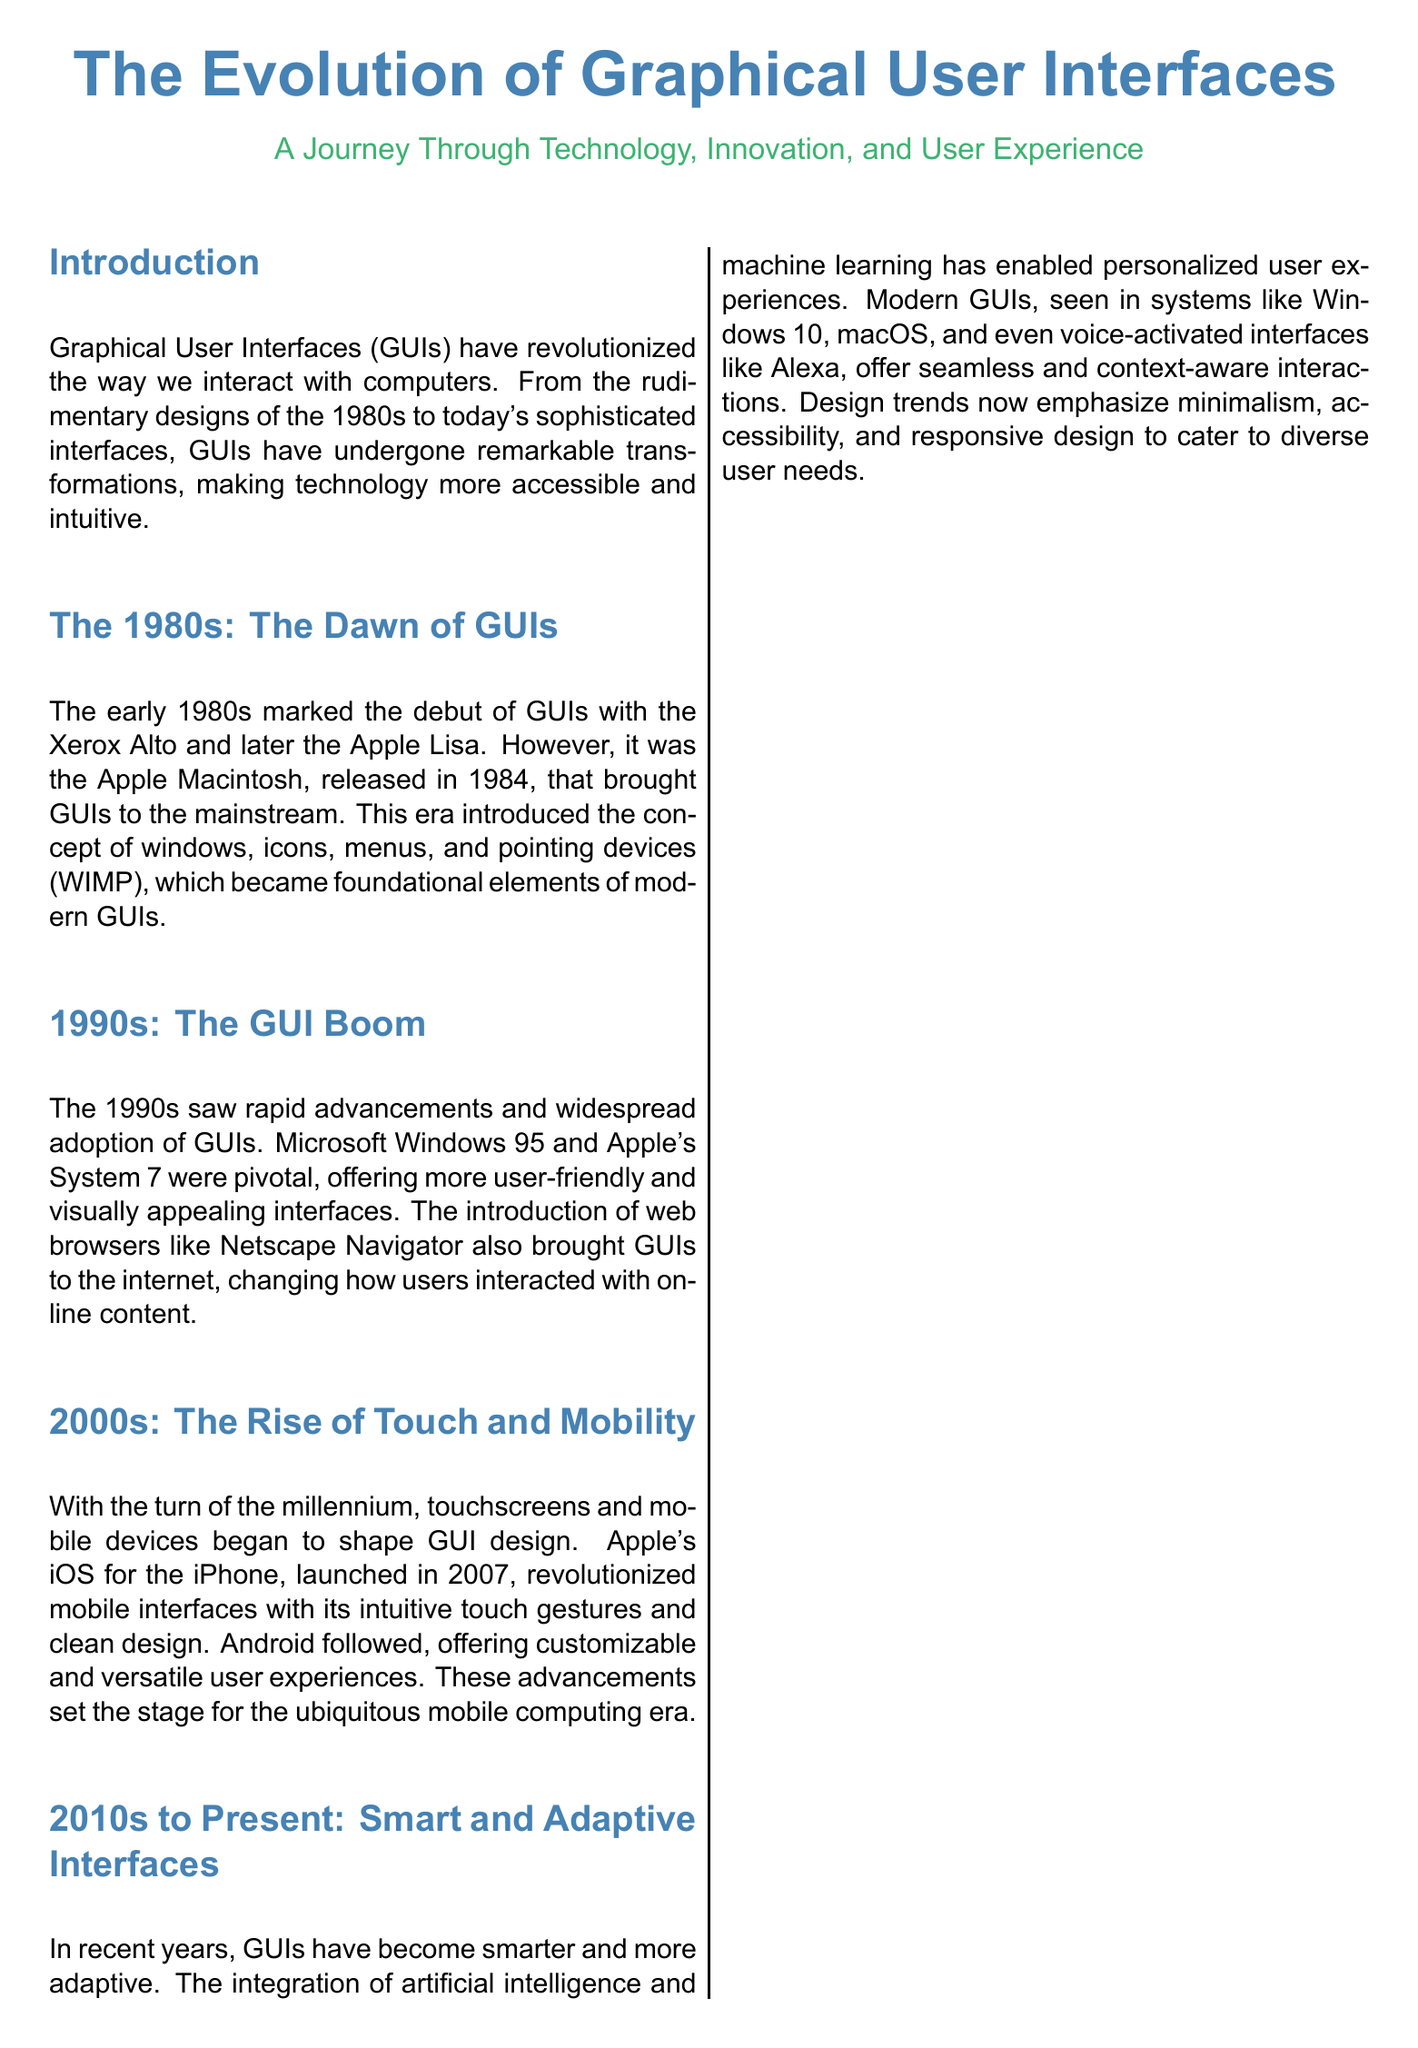What year did the Apple Macintosh launch? The document states that the Apple Macintosh was launched in 1984.
Answer: 1984 What was the pivotal Windows release in 1995? The document mentions that Windows 95 popularized the Start menu and taskbar.
Answer: Windows 95 Which iOS version revolutionized mobile interfaces? The document indicates that iOS for the iPhone, launched in 2007, revolutionized mobile interfaces.
Answer: iOS What design principle became common in the 2010s? The document notes that modern GUIs emphasize minimalism, accessibility, and responsive design in the 2010s to present.
Answer: Minimalism Which pioneering software was the first computer with a GUI-based OS? The document lists Xerox Alto as the first computer with a GUI-based OS.
Answer: Xerox Alto In what decade did GUIs become widespread due to Microsoft Windows 95 and Apple's System 7? The document specifies the 1990s as the era when GUIs became widespread.
Answer: 1990s What kind of GUI design dominated the 2000s? The document states that the 2000s saw a shift towards skeuomorphism in GUI design.
Answer: Skeuomorphism What event does the Key Milestones box highlight for the year 2015? The document mentions that Windows 10 introduced the concept of a unified platform across devices in 2015.
Answer: Unified platform across devices What significant interface development occurred in 2007? The document states that in 2007, the introduction of the iPhone and iOS revolutionized touch-based GUIs.
Answer: iPhone and iOS 